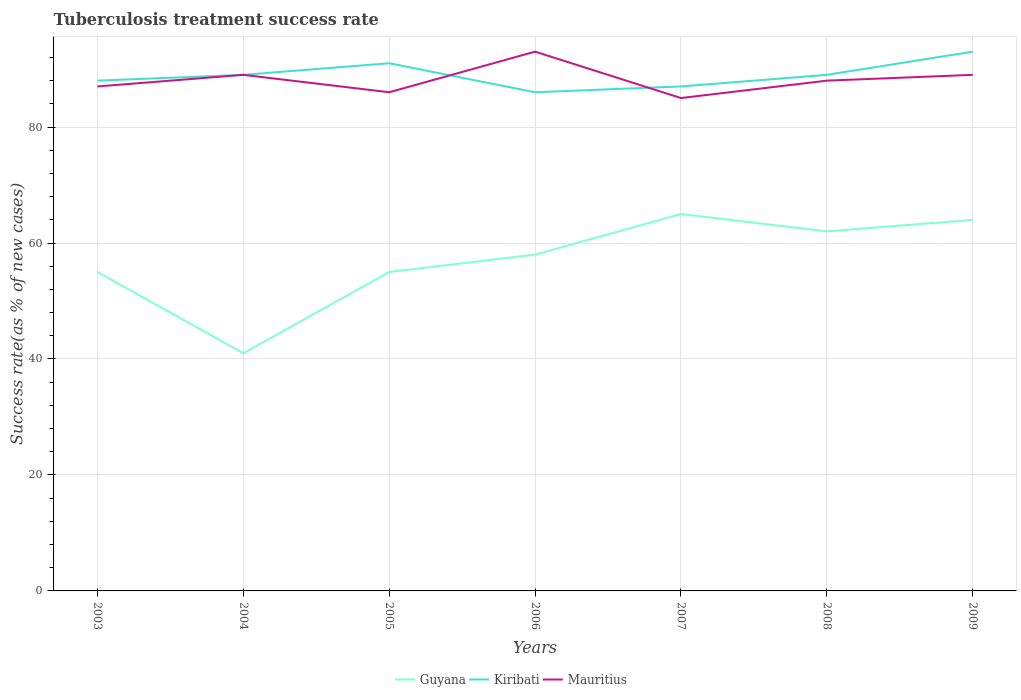How many different coloured lines are there?
Provide a succinct answer. 3. Does the line corresponding to Mauritius intersect with the line corresponding to Guyana?
Offer a terse response. No. In which year was the tuberculosis treatment success rate in Kiribati maximum?
Offer a terse response. 2006. What is the difference between the highest and the lowest tuberculosis treatment success rate in Kiribati?
Provide a succinct answer. 2. Is the tuberculosis treatment success rate in Mauritius strictly greater than the tuberculosis treatment success rate in Guyana over the years?
Your response must be concise. No. How many years are there in the graph?
Ensure brevity in your answer.  7. What is the difference between two consecutive major ticks on the Y-axis?
Your answer should be compact. 20. Does the graph contain grids?
Provide a short and direct response. Yes. Where does the legend appear in the graph?
Your response must be concise. Bottom center. How are the legend labels stacked?
Ensure brevity in your answer.  Horizontal. What is the title of the graph?
Your answer should be very brief. Tuberculosis treatment success rate. Does "Fragile and conflict affected situations" appear as one of the legend labels in the graph?
Ensure brevity in your answer.  No. What is the label or title of the X-axis?
Provide a succinct answer. Years. What is the label or title of the Y-axis?
Make the answer very short. Success rate(as % of new cases). What is the Success rate(as % of new cases) of Guyana in 2003?
Ensure brevity in your answer.  55. What is the Success rate(as % of new cases) of Kiribati in 2003?
Provide a succinct answer. 88. What is the Success rate(as % of new cases) of Guyana in 2004?
Provide a succinct answer. 41. What is the Success rate(as % of new cases) in Kiribati in 2004?
Give a very brief answer. 89. What is the Success rate(as % of new cases) in Mauritius in 2004?
Provide a succinct answer. 89. What is the Success rate(as % of new cases) in Guyana in 2005?
Keep it short and to the point. 55. What is the Success rate(as % of new cases) in Kiribati in 2005?
Your response must be concise. 91. What is the Success rate(as % of new cases) of Guyana in 2006?
Your response must be concise. 58. What is the Success rate(as % of new cases) of Mauritius in 2006?
Offer a very short reply. 93. What is the Success rate(as % of new cases) in Guyana in 2007?
Your answer should be compact. 65. What is the Success rate(as % of new cases) in Kiribati in 2007?
Give a very brief answer. 87. What is the Success rate(as % of new cases) of Mauritius in 2007?
Give a very brief answer. 85. What is the Success rate(as % of new cases) in Kiribati in 2008?
Your response must be concise. 89. What is the Success rate(as % of new cases) in Kiribati in 2009?
Ensure brevity in your answer.  93. What is the Success rate(as % of new cases) of Mauritius in 2009?
Your answer should be compact. 89. Across all years, what is the maximum Success rate(as % of new cases) in Kiribati?
Provide a short and direct response. 93. Across all years, what is the maximum Success rate(as % of new cases) of Mauritius?
Ensure brevity in your answer.  93. What is the total Success rate(as % of new cases) in Kiribati in the graph?
Your response must be concise. 623. What is the total Success rate(as % of new cases) of Mauritius in the graph?
Your answer should be compact. 617. What is the difference between the Success rate(as % of new cases) in Mauritius in 2003 and that in 2004?
Your answer should be compact. -2. What is the difference between the Success rate(as % of new cases) of Kiribati in 2003 and that in 2005?
Your answer should be compact. -3. What is the difference between the Success rate(as % of new cases) of Kiribati in 2003 and that in 2006?
Offer a terse response. 2. What is the difference between the Success rate(as % of new cases) of Mauritius in 2003 and that in 2006?
Offer a terse response. -6. What is the difference between the Success rate(as % of new cases) in Kiribati in 2003 and that in 2007?
Keep it short and to the point. 1. What is the difference between the Success rate(as % of new cases) in Guyana in 2003 and that in 2008?
Provide a short and direct response. -7. What is the difference between the Success rate(as % of new cases) in Mauritius in 2003 and that in 2008?
Your response must be concise. -1. What is the difference between the Success rate(as % of new cases) of Mauritius in 2003 and that in 2009?
Provide a succinct answer. -2. What is the difference between the Success rate(as % of new cases) of Guyana in 2004 and that in 2005?
Offer a very short reply. -14. What is the difference between the Success rate(as % of new cases) of Guyana in 2004 and that in 2006?
Offer a terse response. -17. What is the difference between the Success rate(as % of new cases) in Guyana in 2004 and that in 2007?
Provide a short and direct response. -24. What is the difference between the Success rate(as % of new cases) in Mauritius in 2004 and that in 2007?
Give a very brief answer. 4. What is the difference between the Success rate(as % of new cases) of Guyana in 2004 and that in 2008?
Give a very brief answer. -21. What is the difference between the Success rate(as % of new cases) of Kiribati in 2004 and that in 2008?
Provide a succinct answer. 0. What is the difference between the Success rate(as % of new cases) in Mauritius in 2004 and that in 2008?
Offer a very short reply. 1. What is the difference between the Success rate(as % of new cases) of Kiribati in 2004 and that in 2009?
Your response must be concise. -4. What is the difference between the Success rate(as % of new cases) in Guyana in 2005 and that in 2007?
Ensure brevity in your answer.  -10. What is the difference between the Success rate(as % of new cases) in Kiribati in 2005 and that in 2007?
Your answer should be very brief. 4. What is the difference between the Success rate(as % of new cases) of Guyana in 2005 and that in 2008?
Keep it short and to the point. -7. What is the difference between the Success rate(as % of new cases) of Kiribati in 2005 and that in 2008?
Offer a very short reply. 2. What is the difference between the Success rate(as % of new cases) of Mauritius in 2005 and that in 2008?
Your response must be concise. -2. What is the difference between the Success rate(as % of new cases) of Mauritius in 2005 and that in 2009?
Your response must be concise. -3. What is the difference between the Success rate(as % of new cases) of Guyana in 2006 and that in 2007?
Make the answer very short. -7. What is the difference between the Success rate(as % of new cases) in Kiribati in 2006 and that in 2007?
Make the answer very short. -1. What is the difference between the Success rate(as % of new cases) of Mauritius in 2006 and that in 2007?
Keep it short and to the point. 8. What is the difference between the Success rate(as % of new cases) of Guyana in 2006 and that in 2008?
Your answer should be compact. -4. What is the difference between the Success rate(as % of new cases) of Mauritius in 2006 and that in 2008?
Provide a short and direct response. 5. What is the difference between the Success rate(as % of new cases) in Mauritius in 2006 and that in 2009?
Make the answer very short. 4. What is the difference between the Success rate(as % of new cases) of Guyana in 2007 and that in 2008?
Offer a terse response. 3. What is the difference between the Success rate(as % of new cases) in Mauritius in 2007 and that in 2008?
Keep it short and to the point. -3. What is the difference between the Success rate(as % of new cases) in Guyana in 2007 and that in 2009?
Offer a terse response. 1. What is the difference between the Success rate(as % of new cases) of Kiribati in 2008 and that in 2009?
Ensure brevity in your answer.  -4. What is the difference between the Success rate(as % of new cases) in Guyana in 2003 and the Success rate(as % of new cases) in Kiribati in 2004?
Your answer should be very brief. -34. What is the difference between the Success rate(as % of new cases) of Guyana in 2003 and the Success rate(as % of new cases) of Mauritius in 2004?
Offer a terse response. -34. What is the difference between the Success rate(as % of new cases) in Guyana in 2003 and the Success rate(as % of new cases) in Kiribati in 2005?
Ensure brevity in your answer.  -36. What is the difference between the Success rate(as % of new cases) in Guyana in 2003 and the Success rate(as % of new cases) in Mauritius in 2005?
Your answer should be compact. -31. What is the difference between the Success rate(as % of new cases) of Kiribati in 2003 and the Success rate(as % of new cases) of Mauritius in 2005?
Give a very brief answer. 2. What is the difference between the Success rate(as % of new cases) in Guyana in 2003 and the Success rate(as % of new cases) in Kiribati in 2006?
Offer a terse response. -31. What is the difference between the Success rate(as % of new cases) of Guyana in 2003 and the Success rate(as % of new cases) of Mauritius in 2006?
Ensure brevity in your answer.  -38. What is the difference between the Success rate(as % of new cases) in Kiribati in 2003 and the Success rate(as % of new cases) in Mauritius in 2006?
Keep it short and to the point. -5. What is the difference between the Success rate(as % of new cases) of Guyana in 2003 and the Success rate(as % of new cases) of Kiribati in 2007?
Your answer should be compact. -32. What is the difference between the Success rate(as % of new cases) of Guyana in 2003 and the Success rate(as % of new cases) of Mauritius in 2007?
Keep it short and to the point. -30. What is the difference between the Success rate(as % of new cases) of Kiribati in 2003 and the Success rate(as % of new cases) of Mauritius in 2007?
Provide a short and direct response. 3. What is the difference between the Success rate(as % of new cases) of Guyana in 2003 and the Success rate(as % of new cases) of Kiribati in 2008?
Ensure brevity in your answer.  -34. What is the difference between the Success rate(as % of new cases) in Guyana in 2003 and the Success rate(as % of new cases) in Mauritius in 2008?
Make the answer very short. -33. What is the difference between the Success rate(as % of new cases) in Guyana in 2003 and the Success rate(as % of new cases) in Kiribati in 2009?
Provide a succinct answer. -38. What is the difference between the Success rate(as % of new cases) in Guyana in 2003 and the Success rate(as % of new cases) in Mauritius in 2009?
Offer a terse response. -34. What is the difference between the Success rate(as % of new cases) in Kiribati in 2003 and the Success rate(as % of new cases) in Mauritius in 2009?
Offer a very short reply. -1. What is the difference between the Success rate(as % of new cases) in Guyana in 2004 and the Success rate(as % of new cases) in Mauritius in 2005?
Your answer should be compact. -45. What is the difference between the Success rate(as % of new cases) in Guyana in 2004 and the Success rate(as % of new cases) in Kiribati in 2006?
Make the answer very short. -45. What is the difference between the Success rate(as % of new cases) in Guyana in 2004 and the Success rate(as % of new cases) in Mauritius in 2006?
Provide a succinct answer. -52. What is the difference between the Success rate(as % of new cases) in Guyana in 2004 and the Success rate(as % of new cases) in Kiribati in 2007?
Provide a succinct answer. -46. What is the difference between the Success rate(as % of new cases) in Guyana in 2004 and the Success rate(as % of new cases) in Mauritius in 2007?
Your answer should be compact. -44. What is the difference between the Success rate(as % of new cases) in Guyana in 2004 and the Success rate(as % of new cases) in Kiribati in 2008?
Provide a short and direct response. -48. What is the difference between the Success rate(as % of new cases) of Guyana in 2004 and the Success rate(as % of new cases) of Mauritius in 2008?
Offer a terse response. -47. What is the difference between the Success rate(as % of new cases) in Guyana in 2004 and the Success rate(as % of new cases) in Kiribati in 2009?
Offer a terse response. -52. What is the difference between the Success rate(as % of new cases) of Guyana in 2004 and the Success rate(as % of new cases) of Mauritius in 2009?
Offer a very short reply. -48. What is the difference between the Success rate(as % of new cases) in Guyana in 2005 and the Success rate(as % of new cases) in Kiribati in 2006?
Provide a succinct answer. -31. What is the difference between the Success rate(as % of new cases) of Guyana in 2005 and the Success rate(as % of new cases) of Mauritius in 2006?
Provide a short and direct response. -38. What is the difference between the Success rate(as % of new cases) of Guyana in 2005 and the Success rate(as % of new cases) of Kiribati in 2007?
Offer a very short reply. -32. What is the difference between the Success rate(as % of new cases) in Guyana in 2005 and the Success rate(as % of new cases) in Mauritius in 2007?
Offer a terse response. -30. What is the difference between the Success rate(as % of new cases) in Kiribati in 2005 and the Success rate(as % of new cases) in Mauritius in 2007?
Make the answer very short. 6. What is the difference between the Success rate(as % of new cases) in Guyana in 2005 and the Success rate(as % of new cases) in Kiribati in 2008?
Your response must be concise. -34. What is the difference between the Success rate(as % of new cases) in Guyana in 2005 and the Success rate(as % of new cases) in Mauritius in 2008?
Provide a succinct answer. -33. What is the difference between the Success rate(as % of new cases) in Kiribati in 2005 and the Success rate(as % of new cases) in Mauritius in 2008?
Ensure brevity in your answer.  3. What is the difference between the Success rate(as % of new cases) of Guyana in 2005 and the Success rate(as % of new cases) of Kiribati in 2009?
Offer a very short reply. -38. What is the difference between the Success rate(as % of new cases) of Guyana in 2005 and the Success rate(as % of new cases) of Mauritius in 2009?
Keep it short and to the point. -34. What is the difference between the Success rate(as % of new cases) in Kiribati in 2005 and the Success rate(as % of new cases) in Mauritius in 2009?
Provide a short and direct response. 2. What is the difference between the Success rate(as % of new cases) of Guyana in 2006 and the Success rate(as % of new cases) of Kiribati in 2007?
Your answer should be very brief. -29. What is the difference between the Success rate(as % of new cases) of Guyana in 2006 and the Success rate(as % of new cases) of Mauritius in 2007?
Provide a succinct answer. -27. What is the difference between the Success rate(as % of new cases) in Guyana in 2006 and the Success rate(as % of new cases) in Kiribati in 2008?
Your response must be concise. -31. What is the difference between the Success rate(as % of new cases) in Kiribati in 2006 and the Success rate(as % of new cases) in Mauritius in 2008?
Your response must be concise. -2. What is the difference between the Success rate(as % of new cases) in Guyana in 2006 and the Success rate(as % of new cases) in Kiribati in 2009?
Offer a very short reply. -35. What is the difference between the Success rate(as % of new cases) of Guyana in 2006 and the Success rate(as % of new cases) of Mauritius in 2009?
Make the answer very short. -31. What is the difference between the Success rate(as % of new cases) in Guyana in 2007 and the Success rate(as % of new cases) in Mauritius in 2008?
Ensure brevity in your answer.  -23. What is the difference between the Success rate(as % of new cases) in Kiribati in 2007 and the Success rate(as % of new cases) in Mauritius in 2008?
Ensure brevity in your answer.  -1. What is the difference between the Success rate(as % of new cases) in Guyana in 2007 and the Success rate(as % of new cases) in Kiribati in 2009?
Give a very brief answer. -28. What is the difference between the Success rate(as % of new cases) in Kiribati in 2007 and the Success rate(as % of new cases) in Mauritius in 2009?
Keep it short and to the point. -2. What is the difference between the Success rate(as % of new cases) of Guyana in 2008 and the Success rate(as % of new cases) of Kiribati in 2009?
Your answer should be compact. -31. What is the difference between the Success rate(as % of new cases) of Guyana in 2008 and the Success rate(as % of new cases) of Mauritius in 2009?
Keep it short and to the point. -27. What is the difference between the Success rate(as % of new cases) of Kiribati in 2008 and the Success rate(as % of new cases) of Mauritius in 2009?
Offer a terse response. 0. What is the average Success rate(as % of new cases) of Guyana per year?
Your answer should be very brief. 57.14. What is the average Success rate(as % of new cases) in Kiribati per year?
Give a very brief answer. 89. What is the average Success rate(as % of new cases) of Mauritius per year?
Your answer should be compact. 88.14. In the year 2003, what is the difference between the Success rate(as % of new cases) in Guyana and Success rate(as % of new cases) in Kiribati?
Keep it short and to the point. -33. In the year 2003, what is the difference between the Success rate(as % of new cases) in Guyana and Success rate(as % of new cases) in Mauritius?
Your answer should be very brief. -32. In the year 2003, what is the difference between the Success rate(as % of new cases) in Kiribati and Success rate(as % of new cases) in Mauritius?
Give a very brief answer. 1. In the year 2004, what is the difference between the Success rate(as % of new cases) in Guyana and Success rate(as % of new cases) in Kiribati?
Your answer should be very brief. -48. In the year 2004, what is the difference between the Success rate(as % of new cases) in Guyana and Success rate(as % of new cases) in Mauritius?
Give a very brief answer. -48. In the year 2004, what is the difference between the Success rate(as % of new cases) in Kiribati and Success rate(as % of new cases) in Mauritius?
Ensure brevity in your answer.  0. In the year 2005, what is the difference between the Success rate(as % of new cases) of Guyana and Success rate(as % of new cases) of Kiribati?
Give a very brief answer. -36. In the year 2005, what is the difference between the Success rate(as % of new cases) in Guyana and Success rate(as % of new cases) in Mauritius?
Offer a terse response. -31. In the year 2006, what is the difference between the Success rate(as % of new cases) in Guyana and Success rate(as % of new cases) in Mauritius?
Provide a succinct answer. -35. In the year 2006, what is the difference between the Success rate(as % of new cases) in Kiribati and Success rate(as % of new cases) in Mauritius?
Make the answer very short. -7. In the year 2007, what is the difference between the Success rate(as % of new cases) of Kiribati and Success rate(as % of new cases) of Mauritius?
Your answer should be compact. 2. In the year 2008, what is the difference between the Success rate(as % of new cases) of Guyana and Success rate(as % of new cases) of Kiribati?
Offer a very short reply. -27. In the year 2008, what is the difference between the Success rate(as % of new cases) in Kiribati and Success rate(as % of new cases) in Mauritius?
Make the answer very short. 1. What is the ratio of the Success rate(as % of new cases) of Guyana in 2003 to that in 2004?
Provide a short and direct response. 1.34. What is the ratio of the Success rate(as % of new cases) of Kiribati in 2003 to that in 2004?
Provide a short and direct response. 0.99. What is the ratio of the Success rate(as % of new cases) of Mauritius in 2003 to that in 2004?
Provide a short and direct response. 0.98. What is the ratio of the Success rate(as % of new cases) of Guyana in 2003 to that in 2005?
Make the answer very short. 1. What is the ratio of the Success rate(as % of new cases) of Mauritius in 2003 to that in 2005?
Your answer should be compact. 1.01. What is the ratio of the Success rate(as % of new cases) of Guyana in 2003 to that in 2006?
Your answer should be very brief. 0.95. What is the ratio of the Success rate(as % of new cases) of Kiribati in 2003 to that in 2006?
Your response must be concise. 1.02. What is the ratio of the Success rate(as % of new cases) of Mauritius in 2003 to that in 2006?
Your answer should be compact. 0.94. What is the ratio of the Success rate(as % of new cases) in Guyana in 2003 to that in 2007?
Give a very brief answer. 0.85. What is the ratio of the Success rate(as % of new cases) in Kiribati in 2003 to that in 2007?
Keep it short and to the point. 1.01. What is the ratio of the Success rate(as % of new cases) of Mauritius in 2003 to that in 2007?
Offer a terse response. 1.02. What is the ratio of the Success rate(as % of new cases) in Guyana in 2003 to that in 2008?
Keep it short and to the point. 0.89. What is the ratio of the Success rate(as % of new cases) in Guyana in 2003 to that in 2009?
Provide a short and direct response. 0.86. What is the ratio of the Success rate(as % of new cases) of Kiribati in 2003 to that in 2009?
Offer a terse response. 0.95. What is the ratio of the Success rate(as % of new cases) in Mauritius in 2003 to that in 2009?
Give a very brief answer. 0.98. What is the ratio of the Success rate(as % of new cases) in Guyana in 2004 to that in 2005?
Offer a terse response. 0.75. What is the ratio of the Success rate(as % of new cases) of Kiribati in 2004 to that in 2005?
Provide a short and direct response. 0.98. What is the ratio of the Success rate(as % of new cases) in Mauritius in 2004 to that in 2005?
Your response must be concise. 1.03. What is the ratio of the Success rate(as % of new cases) in Guyana in 2004 to that in 2006?
Make the answer very short. 0.71. What is the ratio of the Success rate(as % of new cases) in Kiribati in 2004 to that in 2006?
Make the answer very short. 1.03. What is the ratio of the Success rate(as % of new cases) of Mauritius in 2004 to that in 2006?
Provide a succinct answer. 0.96. What is the ratio of the Success rate(as % of new cases) in Guyana in 2004 to that in 2007?
Offer a very short reply. 0.63. What is the ratio of the Success rate(as % of new cases) of Mauritius in 2004 to that in 2007?
Provide a succinct answer. 1.05. What is the ratio of the Success rate(as % of new cases) of Guyana in 2004 to that in 2008?
Provide a succinct answer. 0.66. What is the ratio of the Success rate(as % of new cases) of Kiribati in 2004 to that in 2008?
Make the answer very short. 1. What is the ratio of the Success rate(as % of new cases) in Mauritius in 2004 to that in 2008?
Your answer should be very brief. 1.01. What is the ratio of the Success rate(as % of new cases) in Guyana in 2004 to that in 2009?
Offer a very short reply. 0.64. What is the ratio of the Success rate(as % of new cases) in Mauritius in 2004 to that in 2009?
Offer a terse response. 1. What is the ratio of the Success rate(as % of new cases) of Guyana in 2005 to that in 2006?
Keep it short and to the point. 0.95. What is the ratio of the Success rate(as % of new cases) in Kiribati in 2005 to that in 2006?
Offer a terse response. 1.06. What is the ratio of the Success rate(as % of new cases) in Mauritius in 2005 to that in 2006?
Give a very brief answer. 0.92. What is the ratio of the Success rate(as % of new cases) in Guyana in 2005 to that in 2007?
Provide a succinct answer. 0.85. What is the ratio of the Success rate(as % of new cases) of Kiribati in 2005 to that in 2007?
Your response must be concise. 1.05. What is the ratio of the Success rate(as % of new cases) of Mauritius in 2005 to that in 2007?
Provide a short and direct response. 1.01. What is the ratio of the Success rate(as % of new cases) in Guyana in 2005 to that in 2008?
Offer a terse response. 0.89. What is the ratio of the Success rate(as % of new cases) of Kiribati in 2005 to that in 2008?
Your answer should be compact. 1.02. What is the ratio of the Success rate(as % of new cases) in Mauritius in 2005 to that in 2008?
Your answer should be compact. 0.98. What is the ratio of the Success rate(as % of new cases) in Guyana in 2005 to that in 2009?
Give a very brief answer. 0.86. What is the ratio of the Success rate(as % of new cases) in Kiribati in 2005 to that in 2009?
Your response must be concise. 0.98. What is the ratio of the Success rate(as % of new cases) in Mauritius in 2005 to that in 2009?
Offer a very short reply. 0.97. What is the ratio of the Success rate(as % of new cases) of Guyana in 2006 to that in 2007?
Ensure brevity in your answer.  0.89. What is the ratio of the Success rate(as % of new cases) in Kiribati in 2006 to that in 2007?
Your response must be concise. 0.99. What is the ratio of the Success rate(as % of new cases) in Mauritius in 2006 to that in 2007?
Your response must be concise. 1.09. What is the ratio of the Success rate(as % of new cases) in Guyana in 2006 to that in 2008?
Make the answer very short. 0.94. What is the ratio of the Success rate(as % of new cases) in Kiribati in 2006 to that in 2008?
Make the answer very short. 0.97. What is the ratio of the Success rate(as % of new cases) of Mauritius in 2006 to that in 2008?
Provide a short and direct response. 1.06. What is the ratio of the Success rate(as % of new cases) of Guyana in 2006 to that in 2009?
Offer a terse response. 0.91. What is the ratio of the Success rate(as % of new cases) of Kiribati in 2006 to that in 2009?
Provide a succinct answer. 0.92. What is the ratio of the Success rate(as % of new cases) in Mauritius in 2006 to that in 2009?
Ensure brevity in your answer.  1.04. What is the ratio of the Success rate(as % of new cases) of Guyana in 2007 to that in 2008?
Your answer should be very brief. 1.05. What is the ratio of the Success rate(as % of new cases) in Kiribati in 2007 to that in 2008?
Your answer should be very brief. 0.98. What is the ratio of the Success rate(as % of new cases) in Mauritius in 2007 to that in 2008?
Provide a succinct answer. 0.97. What is the ratio of the Success rate(as % of new cases) of Guyana in 2007 to that in 2009?
Offer a terse response. 1.02. What is the ratio of the Success rate(as % of new cases) in Kiribati in 2007 to that in 2009?
Provide a short and direct response. 0.94. What is the ratio of the Success rate(as % of new cases) of Mauritius in 2007 to that in 2009?
Offer a very short reply. 0.96. What is the ratio of the Success rate(as % of new cases) in Guyana in 2008 to that in 2009?
Provide a succinct answer. 0.97. What is the ratio of the Success rate(as % of new cases) in Mauritius in 2008 to that in 2009?
Provide a succinct answer. 0.99. What is the difference between the highest and the second highest Success rate(as % of new cases) in Kiribati?
Your answer should be compact. 2. What is the difference between the highest and the lowest Success rate(as % of new cases) of Kiribati?
Ensure brevity in your answer.  7. 